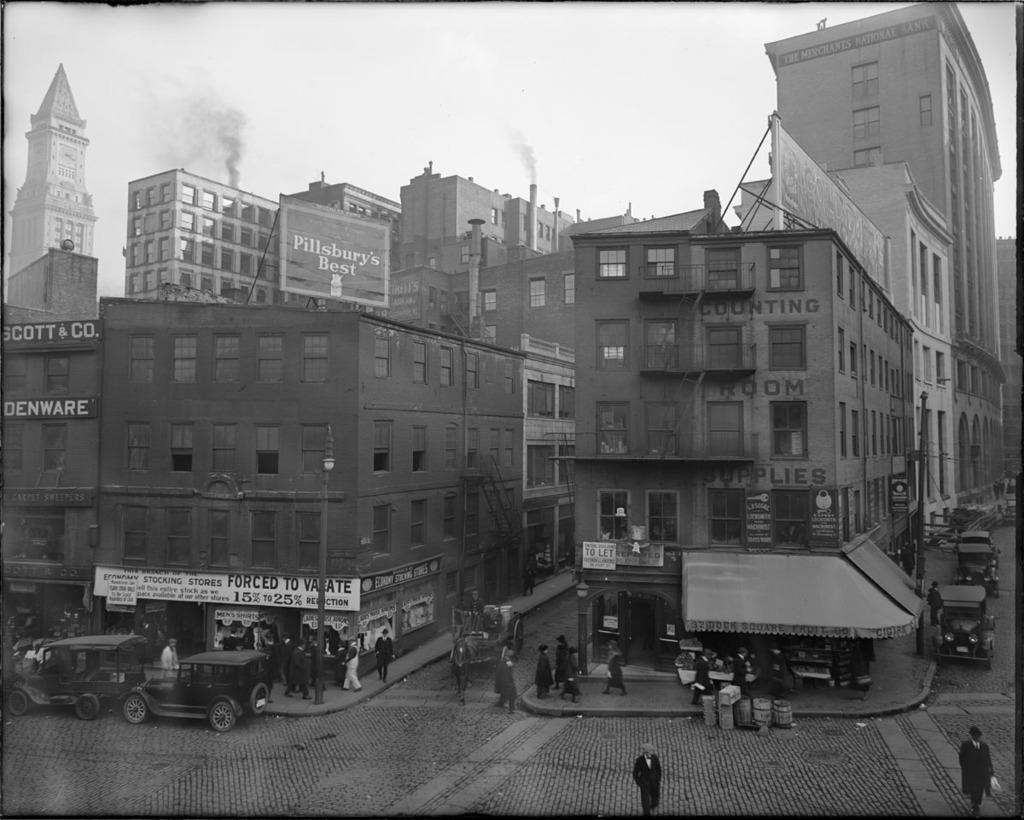Describe this image in one or two sentences. In this image I can see the black and white image in which I can see the road, few persons standing on the road, few persons standing on the sidewalk, few vehicles on the road, few boards and few buildings. I can see smoke coming from the buildings and the sky in the background. 